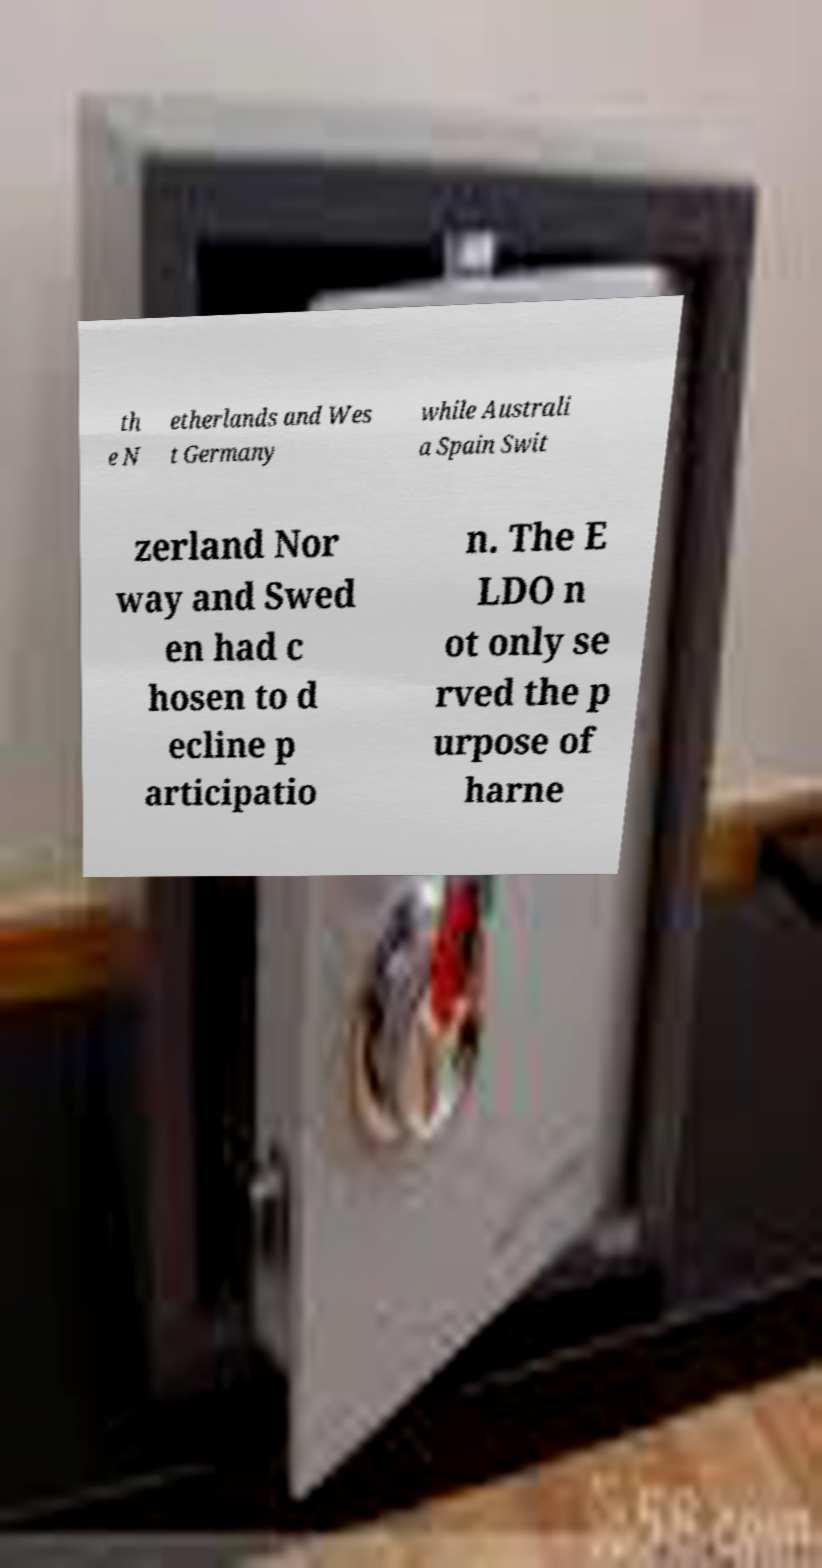I need the written content from this picture converted into text. Can you do that? th e N etherlands and Wes t Germany while Australi a Spain Swit zerland Nor way and Swed en had c hosen to d ecline p articipatio n. The E LDO n ot only se rved the p urpose of harne 